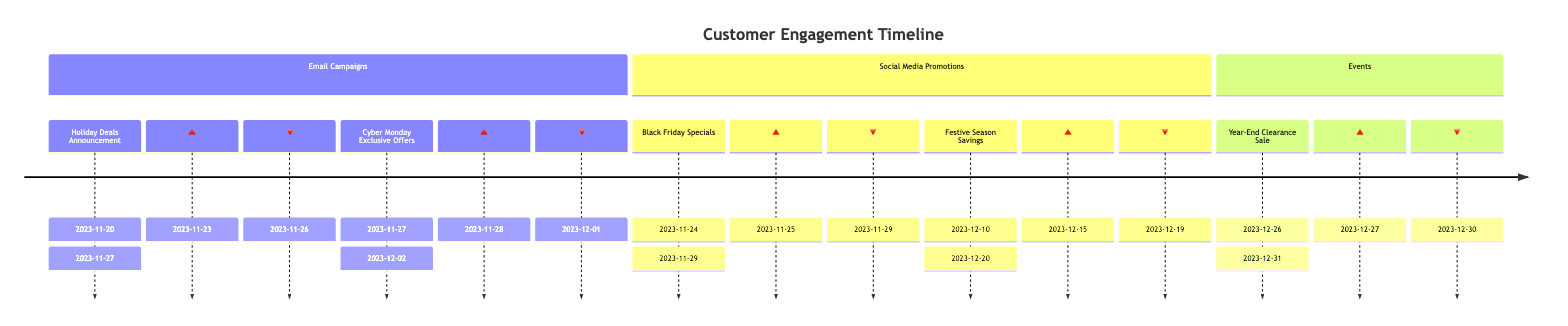What is the start date of the "Holiday Deals Announcement"? The "Holiday Deals Announcement" is an email campaign that starts on the date specified, which is found listed in the timeline under Email Campaigns. Looking at the diagram, we see the start date recorded clearly.
Answer: 2023-11-20 What is the high engagement date for the "Black Friday Specials"? To find the high engagement date, we look for the marker associated with "Black Friday Specials" in the Social Media Promotions section. The diagram denotes this marker with an upward triangle, which indicates the engagement peak.
Answer: 2023-11-25 How many email campaigns are included in the timeline? Count the number of distinct email campaigns listed in the Email Campaigns section of the timeline. In this case, there are two campaigns visible when analyzing the diagram.
Answer: 2 What is the engagement marker indicating low interaction for "Festive Season Savings"? This marker is indicated in the timeline under the "Festive Season Savings" section, represented by a downward triangle. By locating this marker, we identify the specific date on the timeline that denotes a decrease in engagement.
Answer: 2023-12-19 Which event has the highest engagement marker? To determine this, we need to check all events present in the Events section for their high engagement markers. By evaluating their dates, we see that "Year-End Clearance Sale" has the highest engagement marker noted on December 27th.
Answer: 2023-12-27 What is the duration of the "Cyber Monday Exclusive Offers"? The duration can be calculated by finding the start date and the end date of the "Cyber Monday Exclusive Offers" event in the timeline and determining the period between those two dates. The period spans from November 27 to December 2.
Answer: 6 days When does the "Year-End Clearance Sale" start? The start date is found directly in the Events section of the timeline, where it specifies the beginning date of this event.
Answer: 2023-12-26 What is the engagement status on November 29 for the "Black Friday Specials"? By looking at the markers associated with "Black Friday Specials," we find that November 29 is indicated as a low engagement date. This is identifiable in the Social Media Promotions section of the timeline.
Answer: low engagement 